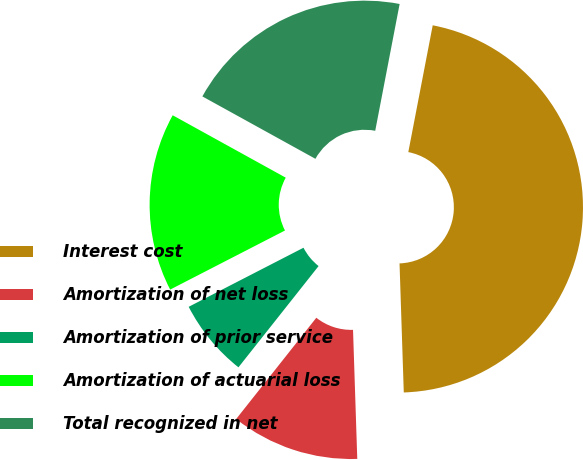<chart> <loc_0><loc_0><loc_500><loc_500><pie_chart><fcel>Interest cost<fcel>Amortization of net loss<fcel>Amortization of prior service<fcel>Amortization of actuarial loss<fcel>Total recognized in net<nl><fcel>46.45%<fcel>11.18%<fcel>6.78%<fcel>15.59%<fcel>20.0%<nl></chart> 